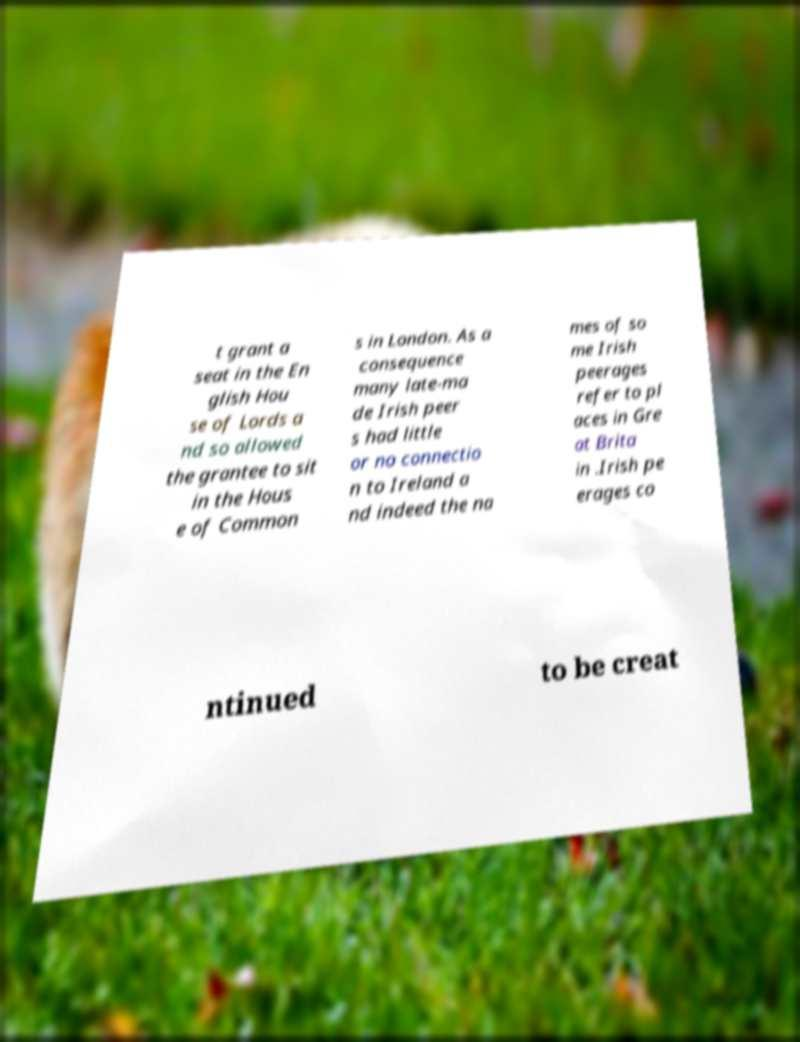Please identify and transcribe the text found in this image. t grant a seat in the En glish Hou se of Lords a nd so allowed the grantee to sit in the Hous e of Common s in London. As a consequence many late-ma de Irish peer s had little or no connectio n to Ireland a nd indeed the na mes of so me Irish peerages refer to pl aces in Gre at Brita in .Irish pe erages co ntinued to be creat 